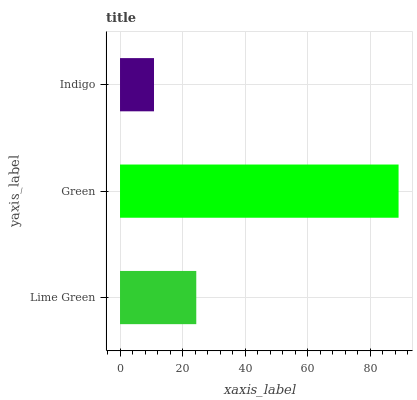Is Indigo the minimum?
Answer yes or no. Yes. Is Green the maximum?
Answer yes or no. Yes. Is Green the minimum?
Answer yes or no. No. Is Indigo the maximum?
Answer yes or no. No. Is Green greater than Indigo?
Answer yes or no. Yes. Is Indigo less than Green?
Answer yes or no. Yes. Is Indigo greater than Green?
Answer yes or no. No. Is Green less than Indigo?
Answer yes or no. No. Is Lime Green the high median?
Answer yes or no. Yes. Is Lime Green the low median?
Answer yes or no. Yes. Is Indigo the high median?
Answer yes or no. No. Is Indigo the low median?
Answer yes or no. No. 